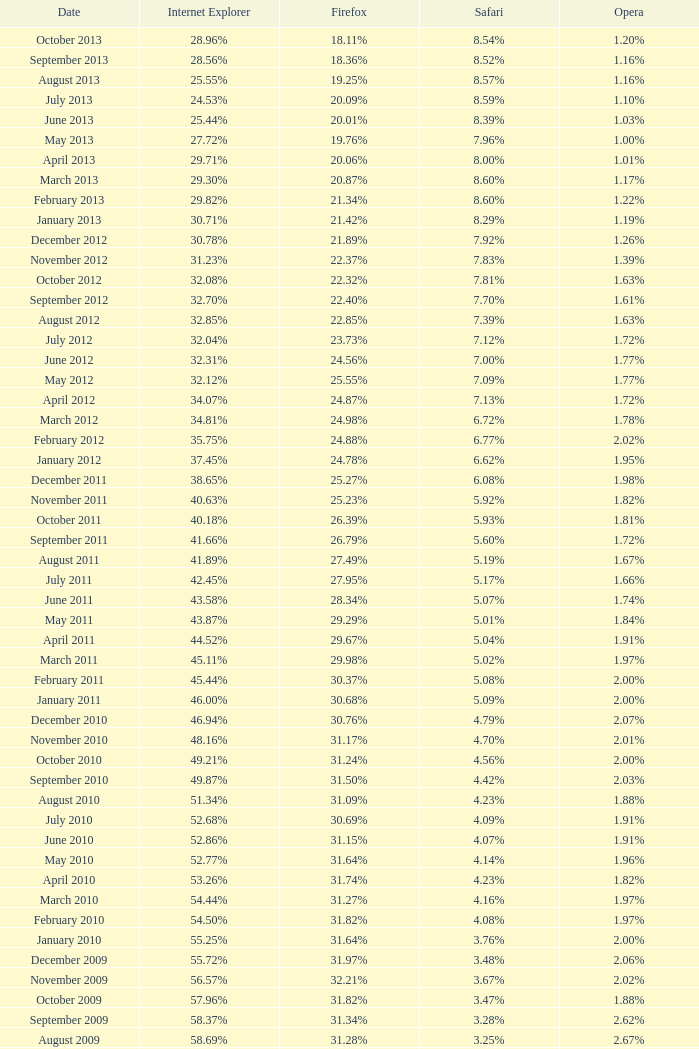In april 2009, what was the proportion of internet explorer usage among browsers? 61.88%. 